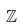<formula> <loc_0><loc_0><loc_500><loc_500>\mathbb { Z }</formula> 